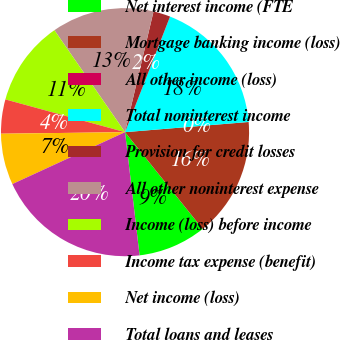Convert chart. <chart><loc_0><loc_0><loc_500><loc_500><pie_chart><fcel>Net interest income (FTE<fcel>Mortgage banking income (loss)<fcel>All other income (loss)<fcel>Total noninterest income<fcel>Provision for credit losses<fcel>All other noninterest expense<fcel>Income (loss) before income<fcel>Income tax expense (benefit)<fcel>Net income (loss)<fcel>Total loans and leases<nl><fcel>8.89%<fcel>15.55%<fcel>0.0%<fcel>17.78%<fcel>2.22%<fcel>13.33%<fcel>11.11%<fcel>4.45%<fcel>6.67%<fcel>20.0%<nl></chart> 